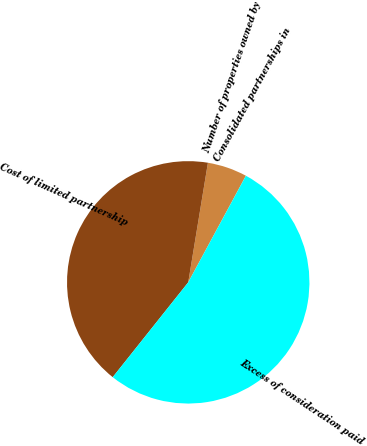Convert chart to OTSL. <chart><loc_0><loc_0><loc_500><loc_500><pie_chart><fcel>Consolidated partnerships in<fcel>Number of properties owned by<fcel>Cost of limited partnership<fcel>Excess of consideration paid<nl><fcel>0.01%<fcel>5.29%<fcel>41.9%<fcel>52.81%<nl></chart> 